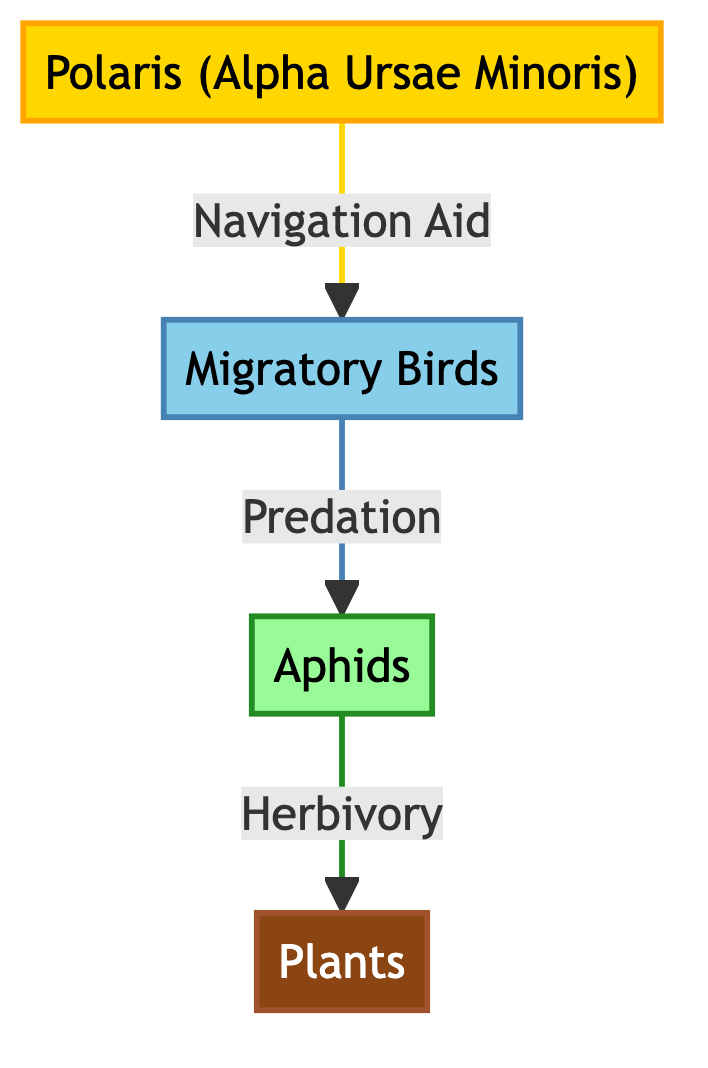What is the first entity in the food chain? The first entity in the food chain is Polaris (Alpha Ursae Minoris), as it is the source that connects to migratory birds.
Answer: Polaris (Alpha Ursae Minoris) How many main entities are present in the diagram? There are four main entities present in the diagram: Polaris, migratory birds, aphids, and plants.
Answer: Four What is the relationship between migratory birds and aphids? The relationship between migratory birds and aphids is that migratory birds prey on aphids, indicating a predator-prey dynamic.
Answer: Predation What type of the star is mentioned in the diagram? The diagram mentions a navigational star, specifically Polaris, which serves as a navigation aid for migratory birds.
Answer: Navigational star What is the role of aphids in the food chain? Aphids serve the role of herbivores in the food chain, as they feed on plants, creating a direct relationship of herbivory.
Answer: Herbivory Which entity is dependent on plants? Aphids are dependent on plants, as they feed on them, highlighting their role in the ecosystem.
Answer: Aphids What color represents migratory birds in the diagram? The color representing migratory birds in the diagram is light blue, showcasing their category distinctively.
Answer: Light blue How does the flow of the food chain begin? The flow of the food chain begins with the star Polaris, which guides migratory birds. This establishes a starting point for the food web.
Answer: With Polaris 